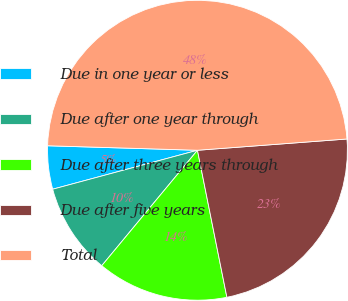<chart> <loc_0><loc_0><loc_500><loc_500><pie_chart><fcel>Due in one year or less<fcel>Due after one year through<fcel>Due after three years through<fcel>Due after five years<fcel>Total<nl><fcel>4.66%<fcel>9.8%<fcel>14.16%<fcel>23.05%<fcel>48.32%<nl></chart> 